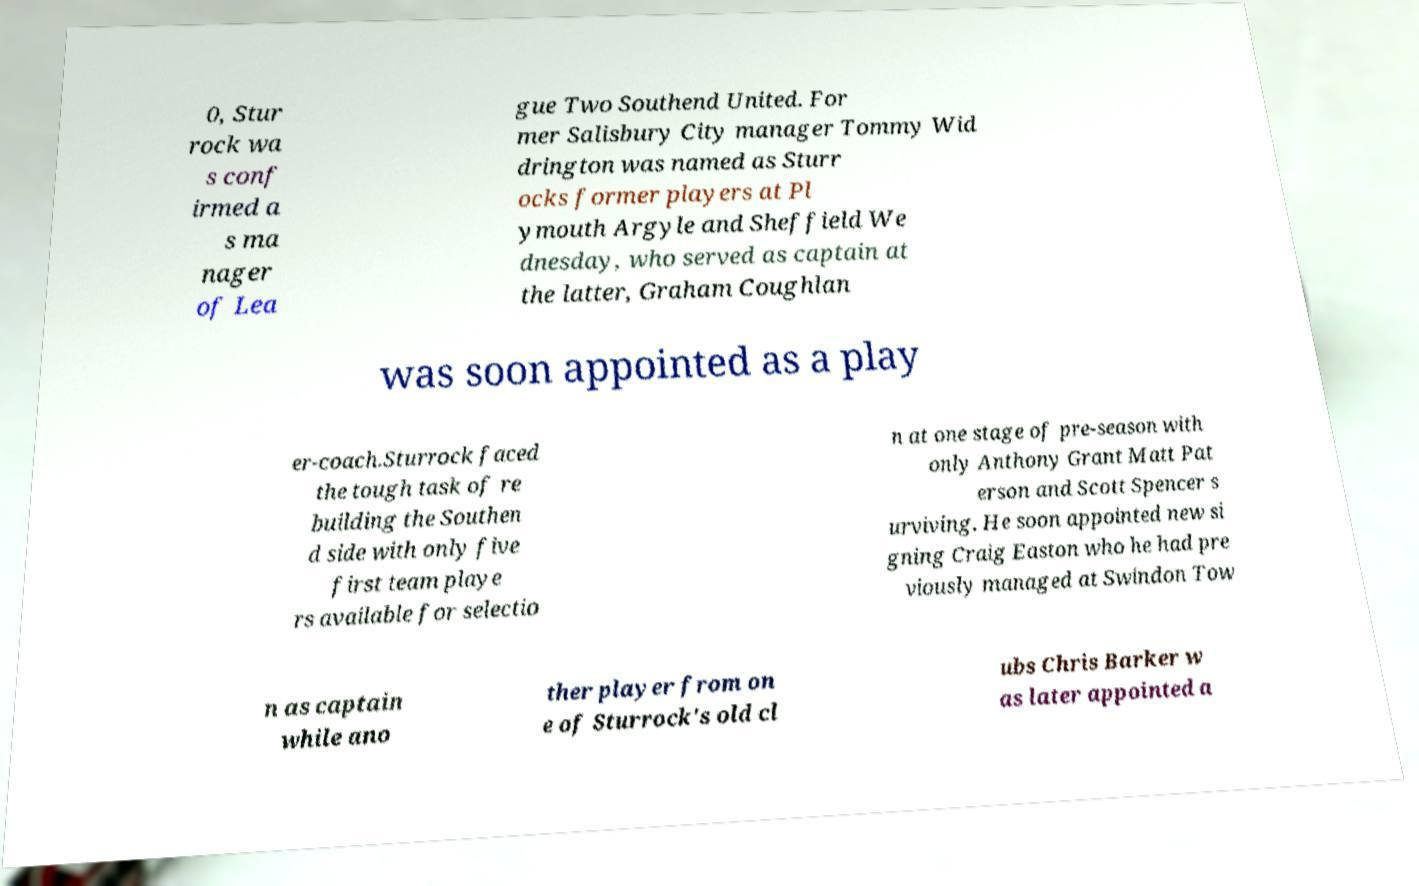Please read and relay the text visible in this image. What does it say? 0, Stur rock wa s conf irmed a s ma nager of Lea gue Two Southend United. For mer Salisbury City manager Tommy Wid drington was named as Sturr ocks former players at Pl ymouth Argyle and Sheffield We dnesday, who served as captain at the latter, Graham Coughlan was soon appointed as a play er-coach.Sturrock faced the tough task of re building the Southen d side with only five first team playe rs available for selectio n at one stage of pre-season with only Anthony Grant Matt Pat erson and Scott Spencer s urviving. He soon appointed new si gning Craig Easton who he had pre viously managed at Swindon Tow n as captain while ano ther player from on e of Sturrock's old cl ubs Chris Barker w as later appointed a 